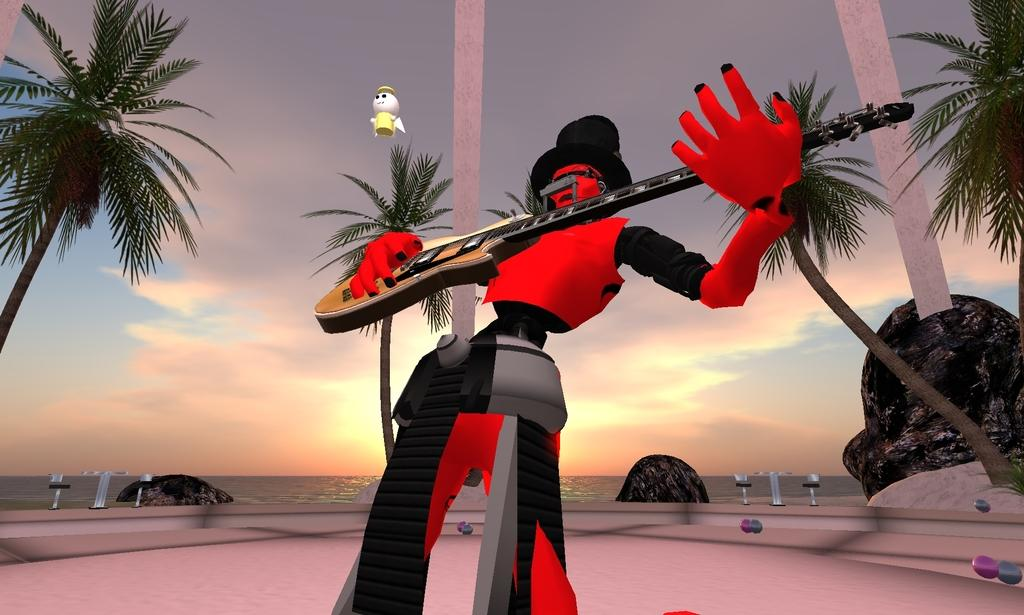What type of scene is depicted in the image? The image is an animated scene. What is the person in the image doing? There is a person playing a guitar in the image. What type of natural elements can be seen in the image? There are trees, rocks, and the ocean visible in the image. What structures can be seen in the image? There are poles in the image. What part of the natural environment is visible in the image? The sky and the ocean are visible in the image. How many coaches are present in the image? There are no coaches present in the image. What type of police vehicle can be seen in the image? There are no police vehicles present in the image. 